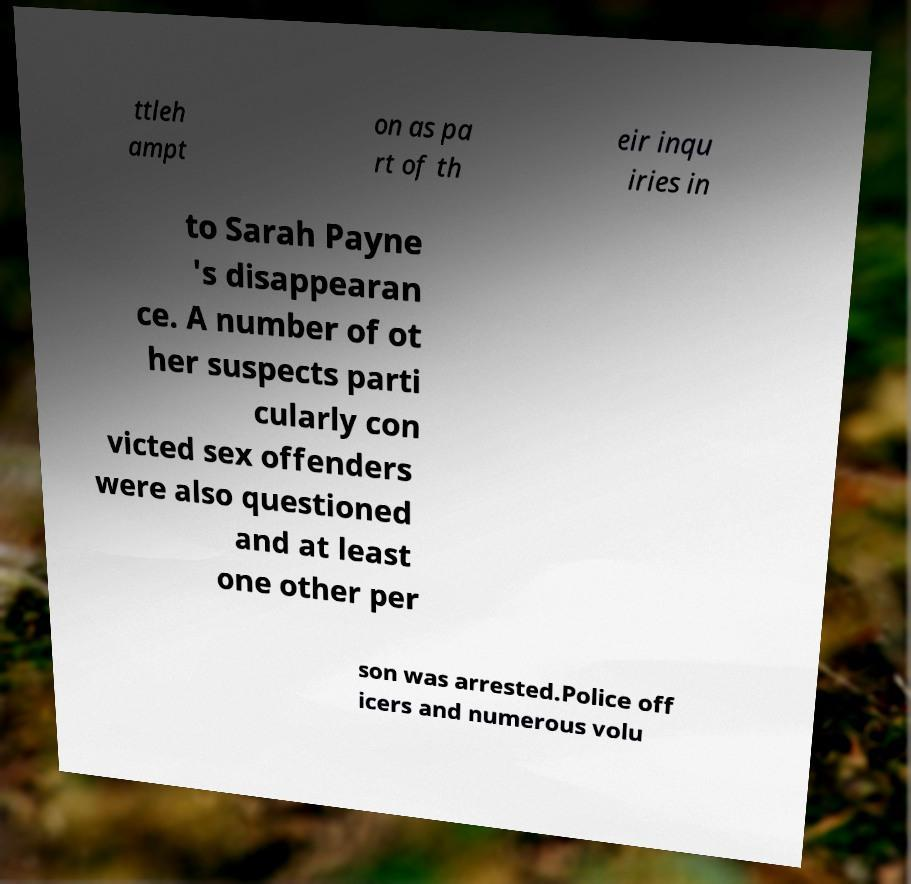Please read and relay the text visible in this image. What does it say? ttleh ampt on as pa rt of th eir inqu iries in to Sarah Payne 's disappearan ce. A number of ot her suspects parti cularly con victed sex offenders were also questioned and at least one other per son was arrested.Police off icers and numerous volu 